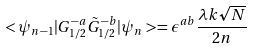<formula> <loc_0><loc_0><loc_500><loc_500>< \psi _ { n - 1 } | { G } ^ { - a } _ { 1 / 2 } \tilde { G } ^ { - b } _ { 1 / 2 } | \psi _ { n } > = \epsilon ^ { a b } \frac { \lambda k \sqrt { N } } { 2 n }</formula> 